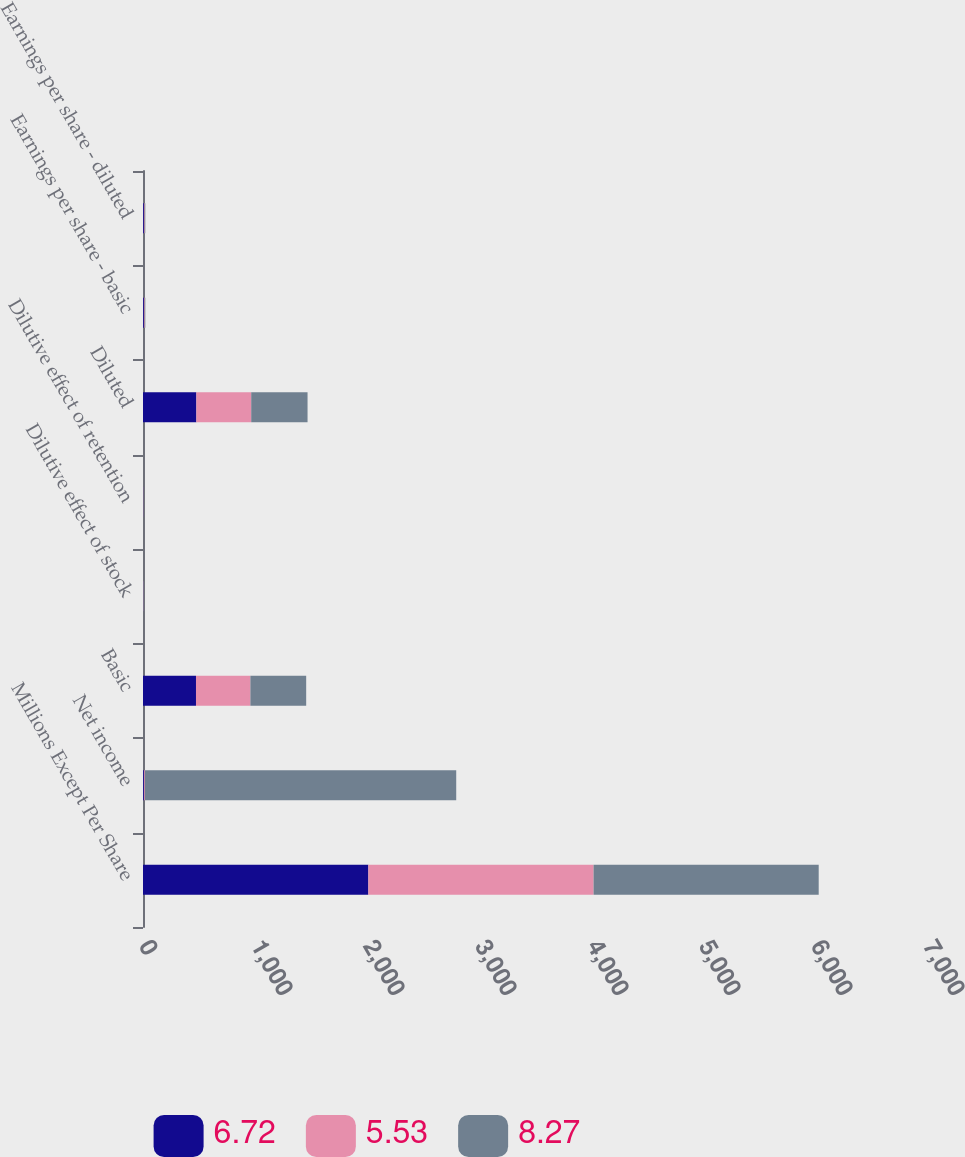Convert chart to OTSL. <chart><loc_0><loc_0><loc_500><loc_500><stacked_bar_chart><ecel><fcel>Millions Except Per Share<fcel>Net income<fcel>Basic<fcel>Dilutive effect of stock<fcel>Dilutive effect of retention<fcel>Diluted<fcel>Earnings per share - basic<fcel>Earnings per share - diluted<nl><fcel>6.72<fcel>2012<fcel>8.3<fcel>473.1<fcel>1.8<fcel>1.6<fcel>476.5<fcel>8.33<fcel>8.27<nl><fcel>5.53<fcel>2011<fcel>8.3<fcel>485.7<fcel>2.6<fcel>1.5<fcel>489.8<fcel>6.78<fcel>6.72<nl><fcel>8.27<fcel>2010<fcel>2780<fcel>498.2<fcel>3.3<fcel>1.4<fcel>502.9<fcel>5.58<fcel>5.53<nl></chart> 